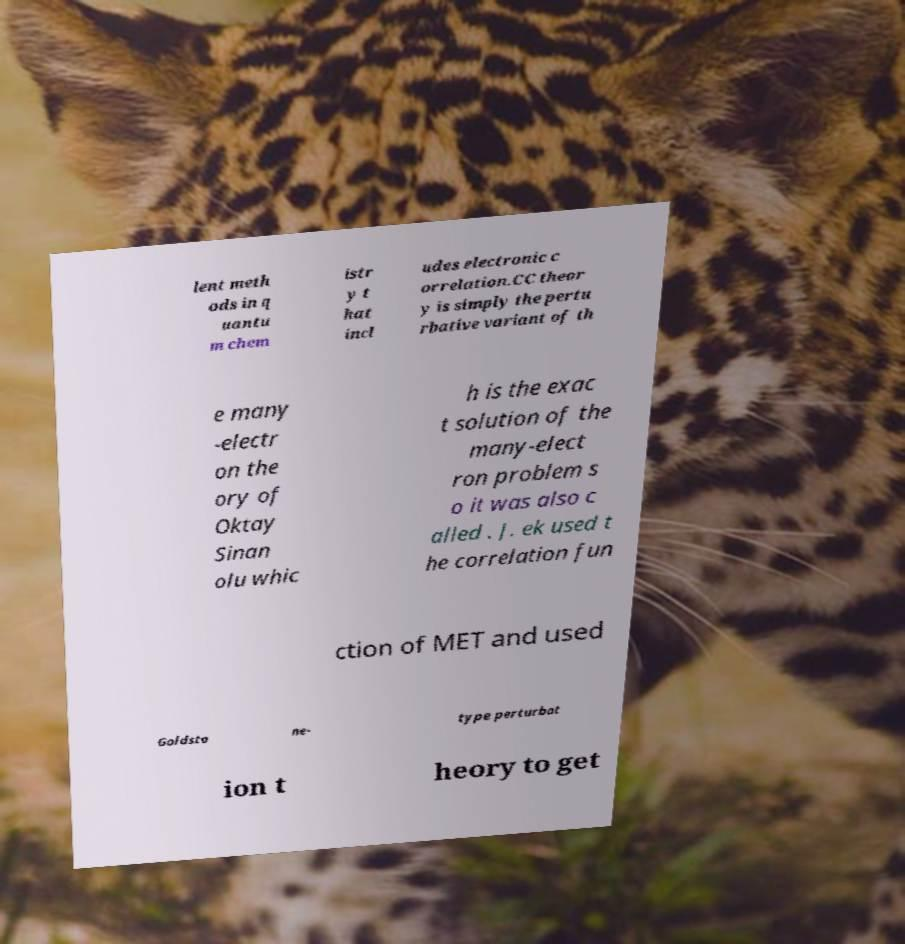Can you accurately transcribe the text from the provided image for me? lent meth ods in q uantu m chem istr y t hat incl udes electronic c orrelation.CC theor y is simply the pertu rbative variant of th e many -electr on the ory of Oktay Sinan olu whic h is the exac t solution of the many-elect ron problem s o it was also c alled . J. ek used t he correlation fun ction of MET and used Goldsto ne- type perturbat ion t heory to get 